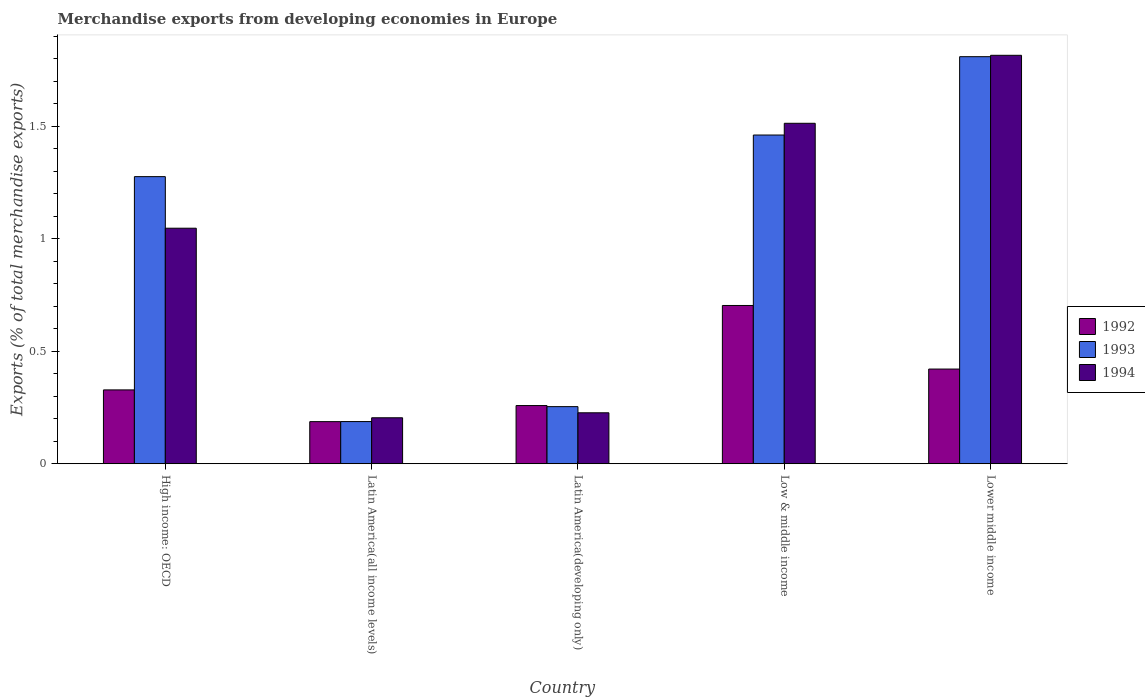How many different coloured bars are there?
Your answer should be compact. 3. How many groups of bars are there?
Offer a very short reply. 5. What is the label of the 4th group of bars from the left?
Make the answer very short. Low & middle income. In how many cases, is the number of bars for a given country not equal to the number of legend labels?
Keep it short and to the point. 0. What is the percentage of total merchandise exports in 1994 in High income: OECD?
Make the answer very short. 1.05. Across all countries, what is the maximum percentage of total merchandise exports in 1992?
Provide a short and direct response. 0.7. Across all countries, what is the minimum percentage of total merchandise exports in 1993?
Ensure brevity in your answer.  0.19. In which country was the percentage of total merchandise exports in 1994 maximum?
Make the answer very short. Lower middle income. In which country was the percentage of total merchandise exports in 1992 minimum?
Give a very brief answer. Latin America(all income levels). What is the total percentage of total merchandise exports in 1994 in the graph?
Provide a succinct answer. 4.8. What is the difference between the percentage of total merchandise exports in 1994 in Latin America(developing only) and that in Lower middle income?
Your answer should be very brief. -1.59. What is the difference between the percentage of total merchandise exports in 1992 in Lower middle income and the percentage of total merchandise exports in 1993 in Low & middle income?
Your answer should be compact. -1.04. What is the average percentage of total merchandise exports in 1992 per country?
Ensure brevity in your answer.  0.38. What is the difference between the percentage of total merchandise exports of/in 1992 and percentage of total merchandise exports of/in 1993 in High income: OECD?
Your answer should be compact. -0.95. What is the ratio of the percentage of total merchandise exports in 1992 in Latin America(all income levels) to that in Lower middle income?
Offer a terse response. 0.44. What is the difference between the highest and the second highest percentage of total merchandise exports in 1993?
Keep it short and to the point. 0.53. What is the difference between the highest and the lowest percentage of total merchandise exports in 1994?
Give a very brief answer. 1.61. In how many countries, is the percentage of total merchandise exports in 1994 greater than the average percentage of total merchandise exports in 1994 taken over all countries?
Your answer should be very brief. 3. What does the 3rd bar from the left in High income: OECD represents?
Keep it short and to the point. 1994. What does the 2nd bar from the right in Latin America(developing only) represents?
Make the answer very short. 1993. How many countries are there in the graph?
Ensure brevity in your answer.  5. What is the difference between two consecutive major ticks on the Y-axis?
Make the answer very short. 0.5. Does the graph contain any zero values?
Your answer should be very brief. No. Does the graph contain grids?
Ensure brevity in your answer.  No. Where does the legend appear in the graph?
Provide a succinct answer. Center right. How many legend labels are there?
Provide a short and direct response. 3. What is the title of the graph?
Give a very brief answer. Merchandise exports from developing economies in Europe. Does "1970" appear as one of the legend labels in the graph?
Offer a terse response. No. What is the label or title of the Y-axis?
Your response must be concise. Exports (% of total merchandise exports). What is the Exports (% of total merchandise exports) in 1992 in High income: OECD?
Make the answer very short. 0.33. What is the Exports (% of total merchandise exports) in 1993 in High income: OECD?
Offer a very short reply. 1.28. What is the Exports (% of total merchandise exports) in 1994 in High income: OECD?
Keep it short and to the point. 1.05. What is the Exports (% of total merchandise exports) of 1992 in Latin America(all income levels)?
Your response must be concise. 0.19. What is the Exports (% of total merchandise exports) in 1993 in Latin America(all income levels)?
Keep it short and to the point. 0.19. What is the Exports (% of total merchandise exports) in 1994 in Latin America(all income levels)?
Give a very brief answer. 0.2. What is the Exports (% of total merchandise exports) in 1992 in Latin America(developing only)?
Your response must be concise. 0.26. What is the Exports (% of total merchandise exports) in 1993 in Latin America(developing only)?
Give a very brief answer. 0.25. What is the Exports (% of total merchandise exports) in 1994 in Latin America(developing only)?
Offer a terse response. 0.23. What is the Exports (% of total merchandise exports) of 1992 in Low & middle income?
Offer a terse response. 0.7. What is the Exports (% of total merchandise exports) of 1993 in Low & middle income?
Give a very brief answer. 1.46. What is the Exports (% of total merchandise exports) of 1994 in Low & middle income?
Your response must be concise. 1.51. What is the Exports (% of total merchandise exports) in 1992 in Lower middle income?
Give a very brief answer. 0.42. What is the Exports (% of total merchandise exports) in 1993 in Lower middle income?
Ensure brevity in your answer.  1.81. What is the Exports (% of total merchandise exports) of 1994 in Lower middle income?
Keep it short and to the point. 1.81. Across all countries, what is the maximum Exports (% of total merchandise exports) of 1992?
Your answer should be very brief. 0.7. Across all countries, what is the maximum Exports (% of total merchandise exports) of 1993?
Your response must be concise. 1.81. Across all countries, what is the maximum Exports (% of total merchandise exports) of 1994?
Provide a succinct answer. 1.81. Across all countries, what is the minimum Exports (% of total merchandise exports) in 1992?
Your response must be concise. 0.19. Across all countries, what is the minimum Exports (% of total merchandise exports) of 1993?
Your answer should be very brief. 0.19. Across all countries, what is the minimum Exports (% of total merchandise exports) in 1994?
Give a very brief answer. 0.2. What is the total Exports (% of total merchandise exports) of 1992 in the graph?
Keep it short and to the point. 1.9. What is the total Exports (% of total merchandise exports) in 1993 in the graph?
Your answer should be compact. 4.98. What is the total Exports (% of total merchandise exports) of 1994 in the graph?
Offer a terse response. 4.8. What is the difference between the Exports (% of total merchandise exports) of 1992 in High income: OECD and that in Latin America(all income levels)?
Your answer should be very brief. 0.14. What is the difference between the Exports (% of total merchandise exports) in 1993 in High income: OECD and that in Latin America(all income levels)?
Keep it short and to the point. 1.09. What is the difference between the Exports (% of total merchandise exports) of 1994 in High income: OECD and that in Latin America(all income levels)?
Provide a succinct answer. 0.84. What is the difference between the Exports (% of total merchandise exports) of 1992 in High income: OECD and that in Latin America(developing only)?
Your answer should be very brief. 0.07. What is the difference between the Exports (% of total merchandise exports) in 1993 in High income: OECD and that in Latin America(developing only)?
Offer a very short reply. 1.02. What is the difference between the Exports (% of total merchandise exports) of 1994 in High income: OECD and that in Latin America(developing only)?
Offer a terse response. 0.82. What is the difference between the Exports (% of total merchandise exports) in 1992 in High income: OECD and that in Low & middle income?
Offer a terse response. -0.38. What is the difference between the Exports (% of total merchandise exports) of 1993 in High income: OECD and that in Low & middle income?
Your answer should be very brief. -0.18. What is the difference between the Exports (% of total merchandise exports) in 1994 in High income: OECD and that in Low & middle income?
Offer a very short reply. -0.47. What is the difference between the Exports (% of total merchandise exports) of 1992 in High income: OECD and that in Lower middle income?
Your answer should be compact. -0.09. What is the difference between the Exports (% of total merchandise exports) of 1993 in High income: OECD and that in Lower middle income?
Your response must be concise. -0.53. What is the difference between the Exports (% of total merchandise exports) of 1994 in High income: OECD and that in Lower middle income?
Make the answer very short. -0.77. What is the difference between the Exports (% of total merchandise exports) in 1992 in Latin America(all income levels) and that in Latin America(developing only)?
Your answer should be compact. -0.07. What is the difference between the Exports (% of total merchandise exports) in 1993 in Latin America(all income levels) and that in Latin America(developing only)?
Provide a succinct answer. -0.07. What is the difference between the Exports (% of total merchandise exports) of 1994 in Latin America(all income levels) and that in Latin America(developing only)?
Make the answer very short. -0.02. What is the difference between the Exports (% of total merchandise exports) of 1992 in Latin America(all income levels) and that in Low & middle income?
Your answer should be compact. -0.52. What is the difference between the Exports (% of total merchandise exports) of 1993 in Latin America(all income levels) and that in Low & middle income?
Make the answer very short. -1.27. What is the difference between the Exports (% of total merchandise exports) of 1994 in Latin America(all income levels) and that in Low & middle income?
Keep it short and to the point. -1.31. What is the difference between the Exports (% of total merchandise exports) in 1992 in Latin America(all income levels) and that in Lower middle income?
Keep it short and to the point. -0.23. What is the difference between the Exports (% of total merchandise exports) of 1993 in Latin America(all income levels) and that in Lower middle income?
Offer a very short reply. -1.62. What is the difference between the Exports (% of total merchandise exports) of 1994 in Latin America(all income levels) and that in Lower middle income?
Give a very brief answer. -1.61. What is the difference between the Exports (% of total merchandise exports) of 1992 in Latin America(developing only) and that in Low & middle income?
Offer a terse response. -0.44. What is the difference between the Exports (% of total merchandise exports) of 1993 in Latin America(developing only) and that in Low & middle income?
Give a very brief answer. -1.21. What is the difference between the Exports (% of total merchandise exports) in 1994 in Latin America(developing only) and that in Low & middle income?
Give a very brief answer. -1.29. What is the difference between the Exports (% of total merchandise exports) in 1992 in Latin America(developing only) and that in Lower middle income?
Your answer should be compact. -0.16. What is the difference between the Exports (% of total merchandise exports) in 1993 in Latin America(developing only) and that in Lower middle income?
Offer a terse response. -1.55. What is the difference between the Exports (% of total merchandise exports) of 1994 in Latin America(developing only) and that in Lower middle income?
Your response must be concise. -1.59. What is the difference between the Exports (% of total merchandise exports) in 1992 in Low & middle income and that in Lower middle income?
Provide a short and direct response. 0.28. What is the difference between the Exports (% of total merchandise exports) in 1993 in Low & middle income and that in Lower middle income?
Provide a short and direct response. -0.35. What is the difference between the Exports (% of total merchandise exports) in 1994 in Low & middle income and that in Lower middle income?
Provide a succinct answer. -0.3. What is the difference between the Exports (% of total merchandise exports) of 1992 in High income: OECD and the Exports (% of total merchandise exports) of 1993 in Latin America(all income levels)?
Offer a terse response. 0.14. What is the difference between the Exports (% of total merchandise exports) in 1992 in High income: OECD and the Exports (% of total merchandise exports) in 1994 in Latin America(all income levels)?
Offer a very short reply. 0.12. What is the difference between the Exports (% of total merchandise exports) of 1993 in High income: OECD and the Exports (% of total merchandise exports) of 1994 in Latin America(all income levels)?
Offer a very short reply. 1.07. What is the difference between the Exports (% of total merchandise exports) in 1992 in High income: OECD and the Exports (% of total merchandise exports) in 1993 in Latin America(developing only)?
Your response must be concise. 0.07. What is the difference between the Exports (% of total merchandise exports) in 1992 in High income: OECD and the Exports (% of total merchandise exports) in 1994 in Latin America(developing only)?
Your answer should be compact. 0.1. What is the difference between the Exports (% of total merchandise exports) of 1993 in High income: OECD and the Exports (% of total merchandise exports) of 1994 in Latin America(developing only)?
Make the answer very short. 1.05. What is the difference between the Exports (% of total merchandise exports) of 1992 in High income: OECD and the Exports (% of total merchandise exports) of 1993 in Low & middle income?
Your response must be concise. -1.13. What is the difference between the Exports (% of total merchandise exports) in 1992 in High income: OECD and the Exports (% of total merchandise exports) in 1994 in Low & middle income?
Keep it short and to the point. -1.18. What is the difference between the Exports (% of total merchandise exports) of 1993 in High income: OECD and the Exports (% of total merchandise exports) of 1994 in Low & middle income?
Make the answer very short. -0.24. What is the difference between the Exports (% of total merchandise exports) of 1992 in High income: OECD and the Exports (% of total merchandise exports) of 1993 in Lower middle income?
Make the answer very short. -1.48. What is the difference between the Exports (% of total merchandise exports) in 1992 in High income: OECD and the Exports (% of total merchandise exports) in 1994 in Lower middle income?
Ensure brevity in your answer.  -1.49. What is the difference between the Exports (% of total merchandise exports) in 1993 in High income: OECD and the Exports (% of total merchandise exports) in 1994 in Lower middle income?
Keep it short and to the point. -0.54. What is the difference between the Exports (% of total merchandise exports) of 1992 in Latin America(all income levels) and the Exports (% of total merchandise exports) of 1993 in Latin America(developing only)?
Your answer should be compact. -0.07. What is the difference between the Exports (% of total merchandise exports) in 1992 in Latin America(all income levels) and the Exports (% of total merchandise exports) in 1994 in Latin America(developing only)?
Provide a short and direct response. -0.04. What is the difference between the Exports (% of total merchandise exports) of 1993 in Latin America(all income levels) and the Exports (% of total merchandise exports) of 1994 in Latin America(developing only)?
Offer a very short reply. -0.04. What is the difference between the Exports (% of total merchandise exports) of 1992 in Latin America(all income levels) and the Exports (% of total merchandise exports) of 1993 in Low & middle income?
Your answer should be compact. -1.27. What is the difference between the Exports (% of total merchandise exports) of 1992 in Latin America(all income levels) and the Exports (% of total merchandise exports) of 1994 in Low & middle income?
Give a very brief answer. -1.33. What is the difference between the Exports (% of total merchandise exports) of 1993 in Latin America(all income levels) and the Exports (% of total merchandise exports) of 1994 in Low & middle income?
Ensure brevity in your answer.  -1.32. What is the difference between the Exports (% of total merchandise exports) of 1992 in Latin America(all income levels) and the Exports (% of total merchandise exports) of 1993 in Lower middle income?
Your answer should be very brief. -1.62. What is the difference between the Exports (% of total merchandise exports) of 1992 in Latin America(all income levels) and the Exports (% of total merchandise exports) of 1994 in Lower middle income?
Offer a very short reply. -1.63. What is the difference between the Exports (% of total merchandise exports) of 1993 in Latin America(all income levels) and the Exports (% of total merchandise exports) of 1994 in Lower middle income?
Provide a succinct answer. -1.63. What is the difference between the Exports (% of total merchandise exports) of 1992 in Latin America(developing only) and the Exports (% of total merchandise exports) of 1993 in Low & middle income?
Keep it short and to the point. -1.2. What is the difference between the Exports (% of total merchandise exports) of 1992 in Latin America(developing only) and the Exports (% of total merchandise exports) of 1994 in Low & middle income?
Give a very brief answer. -1.25. What is the difference between the Exports (% of total merchandise exports) of 1993 in Latin America(developing only) and the Exports (% of total merchandise exports) of 1994 in Low & middle income?
Make the answer very short. -1.26. What is the difference between the Exports (% of total merchandise exports) of 1992 in Latin America(developing only) and the Exports (% of total merchandise exports) of 1993 in Lower middle income?
Give a very brief answer. -1.55. What is the difference between the Exports (% of total merchandise exports) in 1992 in Latin America(developing only) and the Exports (% of total merchandise exports) in 1994 in Lower middle income?
Your answer should be compact. -1.56. What is the difference between the Exports (% of total merchandise exports) of 1993 in Latin America(developing only) and the Exports (% of total merchandise exports) of 1994 in Lower middle income?
Provide a succinct answer. -1.56. What is the difference between the Exports (% of total merchandise exports) of 1992 in Low & middle income and the Exports (% of total merchandise exports) of 1993 in Lower middle income?
Give a very brief answer. -1.11. What is the difference between the Exports (% of total merchandise exports) of 1992 in Low & middle income and the Exports (% of total merchandise exports) of 1994 in Lower middle income?
Give a very brief answer. -1.11. What is the difference between the Exports (% of total merchandise exports) of 1993 in Low & middle income and the Exports (% of total merchandise exports) of 1994 in Lower middle income?
Your response must be concise. -0.35. What is the average Exports (% of total merchandise exports) in 1992 per country?
Your answer should be compact. 0.38. What is the average Exports (% of total merchandise exports) of 1993 per country?
Provide a succinct answer. 1. What is the average Exports (% of total merchandise exports) of 1994 per country?
Provide a succinct answer. 0.96. What is the difference between the Exports (% of total merchandise exports) in 1992 and Exports (% of total merchandise exports) in 1993 in High income: OECD?
Provide a short and direct response. -0.95. What is the difference between the Exports (% of total merchandise exports) in 1992 and Exports (% of total merchandise exports) in 1994 in High income: OECD?
Make the answer very short. -0.72. What is the difference between the Exports (% of total merchandise exports) in 1993 and Exports (% of total merchandise exports) in 1994 in High income: OECD?
Your answer should be compact. 0.23. What is the difference between the Exports (% of total merchandise exports) of 1992 and Exports (% of total merchandise exports) of 1993 in Latin America(all income levels)?
Your answer should be compact. -0. What is the difference between the Exports (% of total merchandise exports) of 1992 and Exports (% of total merchandise exports) of 1994 in Latin America(all income levels)?
Your answer should be compact. -0.02. What is the difference between the Exports (% of total merchandise exports) of 1993 and Exports (% of total merchandise exports) of 1994 in Latin America(all income levels)?
Offer a very short reply. -0.02. What is the difference between the Exports (% of total merchandise exports) of 1992 and Exports (% of total merchandise exports) of 1993 in Latin America(developing only)?
Give a very brief answer. 0. What is the difference between the Exports (% of total merchandise exports) in 1992 and Exports (% of total merchandise exports) in 1994 in Latin America(developing only)?
Give a very brief answer. 0.03. What is the difference between the Exports (% of total merchandise exports) of 1993 and Exports (% of total merchandise exports) of 1994 in Latin America(developing only)?
Offer a terse response. 0.03. What is the difference between the Exports (% of total merchandise exports) in 1992 and Exports (% of total merchandise exports) in 1993 in Low & middle income?
Your response must be concise. -0.76. What is the difference between the Exports (% of total merchandise exports) in 1992 and Exports (% of total merchandise exports) in 1994 in Low & middle income?
Ensure brevity in your answer.  -0.81. What is the difference between the Exports (% of total merchandise exports) in 1993 and Exports (% of total merchandise exports) in 1994 in Low & middle income?
Your response must be concise. -0.05. What is the difference between the Exports (% of total merchandise exports) of 1992 and Exports (% of total merchandise exports) of 1993 in Lower middle income?
Offer a terse response. -1.39. What is the difference between the Exports (% of total merchandise exports) of 1992 and Exports (% of total merchandise exports) of 1994 in Lower middle income?
Keep it short and to the point. -1.39. What is the difference between the Exports (% of total merchandise exports) in 1993 and Exports (% of total merchandise exports) in 1994 in Lower middle income?
Provide a succinct answer. -0.01. What is the ratio of the Exports (% of total merchandise exports) of 1992 in High income: OECD to that in Latin America(all income levels)?
Your response must be concise. 1.75. What is the ratio of the Exports (% of total merchandise exports) in 1993 in High income: OECD to that in Latin America(all income levels)?
Your response must be concise. 6.81. What is the ratio of the Exports (% of total merchandise exports) in 1994 in High income: OECD to that in Latin America(all income levels)?
Keep it short and to the point. 5.12. What is the ratio of the Exports (% of total merchandise exports) in 1992 in High income: OECD to that in Latin America(developing only)?
Keep it short and to the point. 1.27. What is the ratio of the Exports (% of total merchandise exports) in 1993 in High income: OECD to that in Latin America(developing only)?
Your response must be concise. 5.03. What is the ratio of the Exports (% of total merchandise exports) of 1994 in High income: OECD to that in Latin America(developing only)?
Your answer should be compact. 4.62. What is the ratio of the Exports (% of total merchandise exports) in 1992 in High income: OECD to that in Low & middle income?
Your answer should be very brief. 0.47. What is the ratio of the Exports (% of total merchandise exports) in 1993 in High income: OECD to that in Low & middle income?
Provide a short and direct response. 0.87. What is the ratio of the Exports (% of total merchandise exports) of 1994 in High income: OECD to that in Low & middle income?
Offer a terse response. 0.69. What is the ratio of the Exports (% of total merchandise exports) in 1992 in High income: OECD to that in Lower middle income?
Make the answer very short. 0.78. What is the ratio of the Exports (% of total merchandise exports) in 1993 in High income: OECD to that in Lower middle income?
Ensure brevity in your answer.  0.71. What is the ratio of the Exports (% of total merchandise exports) of 1994 in High income: OECD to that in Lower middle income?
Your answer should be very brief. 0.58. What is the ratio of the Exports (% of total merchandise exports) in 1992 in Latin America(all income levels) to that in Latin America(developing only)?
Your answer should be very brief. 0.72. What is the ratio of the Exports (% of total merchandise exports) of 1993 in Latin America(all income levels) to that in Latin America(developing only)?
Ensure brevity in your answer.  0.74. What is the ratio of the Exports (% of total merchandise exports) of 1994 in Latin America(all income levels) to that in Latin America(developing only)?
Offer a very short reply. 0.9. What is the ratio of the Exports (% of total merchandise exports) in 1992 in Latin America(all income levels) to that in Low & middle income?
Make the answer very short. 0.27. What is the ratio of the Exports (% of total merchandise exports) of 1993 in Latin America(all income levels) to that in Low & middle income?
Offer a very short reply. 0.13. What is the ratio of the Exports (% of total merchandise exports) in 1994 in Latin America(all income levels) to that in Low & middle income?
Your answer should be very brief. 0.14. What is the ratio of the Exports (% of total merchandise exports) in 1992 in Latin America(all income levels) to that in Lower middle income?
Offer a terse response. 0.44. What is the ratio of the Exports (% of total merchandise exports) of 1993 in Latin America(all income levels) to that in Lower middle income?
Keep it short and to the point. 0.1. What is the ratio of the Exports (% of total merchandise exports) in 1994 in Latin America(all income levels) to that in Lower middle income?
Ensure brevity in your answer.  0.11. What is the ratio of the Exports (% of total merchandise exports) of 1992 in Latin America(developing only) to that in Low & middle income?
Make the answer very short. 0.37. What is the ratio of the Exports (% of total merchandise exports) in 1993 in Latin America(developing only) to that in Low & middle income?
Offer a very short reply. 0.17. What is the ratio of the Exports (% of total merchandise exports) in 1994 in Latin America(developing only) to that in Low & middle income?
Keep it short and to the point. 0.15. What is the ratio of the Exports (% of total merchandise exports) in 1992 in Latin America(developing only) to that in Lower middle income?
Keep it short and to the point. 0.61. What is the ratio of the Exports (% of total merchandise exports) in 1993 in Latin America(developing only) to that in Lower middle income?
Keep it short and to the point. 0.14. What is the ratio of the Exports (% of total merchandise exports) of 1994 in Latin America(developing only) to that in Lower middle income?
Give a very brief answer. 0.12. What is the ratio of the Exports (% of total merchandise exports) of 1992 in Low & middle income to that in Lower middle income?
Offer a terse response. 1.67. What is the ratio of the Exports (% of total merchandise exports) in 1993 in Low & middle income to that in Lower middle income?
Give a very brief answer. 0.81. What is the ratio of the Exports (% of total merchandise exports) in 1994 in Low & middle income to that in Lower middle income?
Provide a short and direct response. 0.83. What is the difference between the highest and the second highest Exports (% of total merchandise exports) in 1992?
Provide a succinct answer. 0.28. What is the difference between the highest and the second highest Exports (% of total merchandise exports) of 1993?
Provide a short and direct response. 0.35. What is the difference between the highest and the second highest Exports (% of total merchandise exports) in 1994?
Offer a terse response. 0.3. What is the difference between the highest and the lowest Exports (% of total merchandise exports) of 1992?
Ensure brevity in your answer.  0.52. What is the difference between the highest and the lowest Exports (% of total merchandise exports) in 1993?
Keep it short and to the point. 1.62. What is the difference between the highest and the lowest Exports (% of total merchandise exports) of 1994?
Keep it short and to the point. 1.61. 